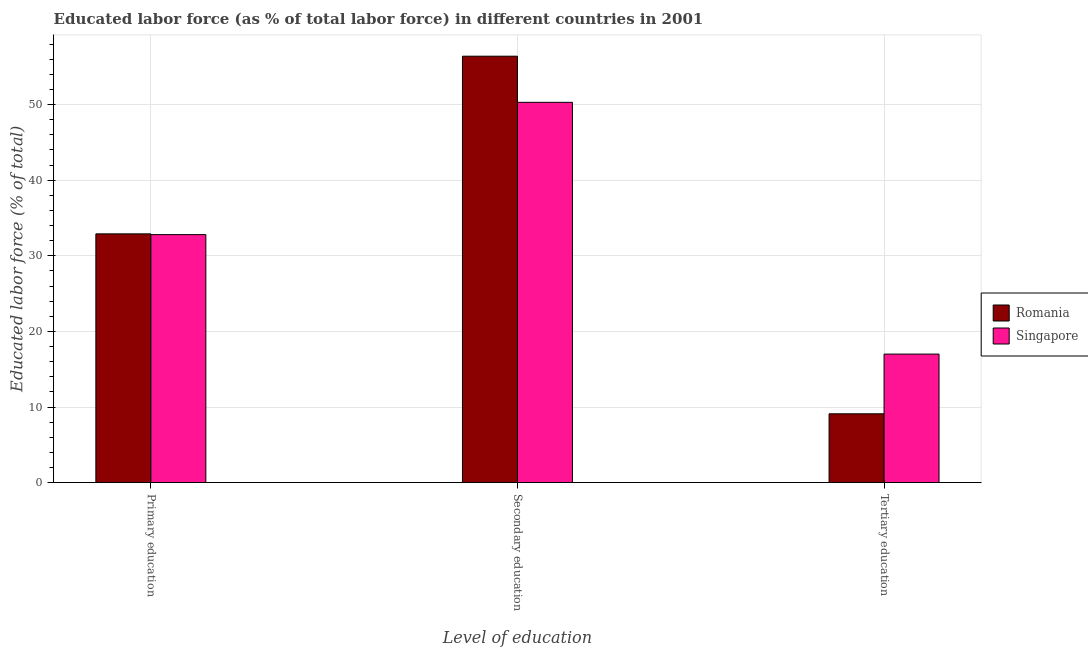How many groups of bars are there?
Offer a terse response. 3. How many bars are there on the 1st tick from the left?
Keep it short and to the point. 2. What is the label of the 1st group of bars from the left?
Keep it short and to the point. Primary education. Across all countries, what is the maximum percentage of labor force who received secondary education?
Your answer should be very brief. 56.4. Across all countries, what is the minimum percentage of labor force who received primary education?
Give a very brief answer. 32.8. In which country was the percentage of labor force who received tertiary education maximum?
Your response must be concise. Singapore. In which country was the percentage of labor force who received primary education minimum?
Your answer should be compact. Singapore. What is the total percentage of labor force who received tertiary education in the graph?
Provide a succinct answer. 26.1. What is the difference between the percentage of labor force who received primary education in Singapore and that in Romania?
Offer a terse response. -0.1. What is the difference between the percentage of labor force who received secondary education in Singapore and the percentage of labor force who received tertiary education in Romania?
Provide a short and direct response. 41.2. What is the average percentage of labor force who received secondary education per country?
Your answer should be compact. 53.35. What is the difference between the percentage of labor force who received secondary education and percentage of labor force who received tertiary education in Romania?
Offer a terse response. 47.3. In how many countries, is the percentage of labor force who received tertiary education greater than 48 %?
Offer a terse response. 0. What is the ratio of the percentage of labor force who received secondary education in Singapore to that in Romania?
Your answer should be compact. 0.89. Is the percentage of labor force who received tertiary education in Romania less than that in Singapore?
Ensure brevity in your answer.  Yes. What is the difference between the highest and the second highest percentage of labor force who received secondary education?
Offer a terse response. 6.1. What is the difference between the highest and the lowest percentage of labor force who received tertiary education?
Provide a succinct answer. 7.9. Is the sum of the percentage of labor force who received secondary education in Romania and Singapore greater than the maximum percentage of labor force who received primary education across all countries?
Give a very brief answer. Yes. What does the 1st bar from the left in Primary education represents?
Your response must be concise. Romania. What does the 1st bar from the right in Secondary education represents?
Your answer should be compact. Singapore. How many bars are there?
Make the answer very short. 6. How many countries are there in the graph?
Ensure brevity in your answer.  2. What is the difference between two consecutive major ticks on the Y-axis?
Ensure brevity in your answer.  10. Does the graph contain grids?
Give a very brief answer. Yes. Where does the legend appear in the graph?
Make the answer very short. Center right. How many legend labels are there?
Keep it short and to the point. 2. How are the legend labels stacked?
Your response must be concise. Vertical. What is the title of the graph?
Keep it short and to the point. Educated labor force (as % of total labor force) in different countries in 2001. What is the label or title of the X-axis?
Ensure brevity in your answer.  Level of education. What is the label or title of the Y-axis?
Provide a succinct answer. Educated labor force (% of total). What is the Educated labor force (% of total) in Romania in Primary education?
Ensure brevity in your answer.  32.9. What is the Educated labor force (% of total) of Singapore in Primary education?
Provide a succinct answer. 32.8. What is the Educated labor force (% of total) in Romania in Secondary education?
Make the answer very short. 56.4. What is the Educated labor force (% of total) of Singapore in Secondary education?
Keep it short and to the point. 50.3. What is the Educated labor force (% of total) of Romania in Tertiary education?
Give a very brief answer. 9.1. Across all Level of education, what is the maximum Educated labor force (% of total) in Romania?
Your response must be concise. 56.4. Across all Level of education, what is the maximum Educated labor force (% of total) in Singapore?
Keep it short and to the point. 50.3. Across all Level of education, what is the minimum Educated labor force (% of total) in Romania?
Offer a very short reply. 9.1. What is the total Educated labor force (% of total) in Romania in the graph?
Give a very brief answer. 98.4. What is the total Educated labor force (% of total) of Singapore in the graph?
Ensure brevity in your answer.  100.1. What is the difference between the Educated labor force (% of total) of Romania in Primary education and that in Secondary education?
Keep it short and to the point. -23.5. What is the difference between the Educated labor force (% of total) in Singapore in Primary education and that in Secondary education?
Offer a terse response. -17.5. What is the difference between the Educated labor force (% of total) of Romania in Primary education and that in Tertiary education?
Ensure brevity in your answer.  23.8. What is the difference between the Educated labor force (% of total) of Singapore in Primary education and that in Tertiary education?
Make the answer very short. 15.8. What is the difference between the Educated labor force (% of total) in Romania in Secondary education and that in Tertiary education?
Provide a short and direct response. 47.3. What is the difference between the Educated labor force (% of total) of Singapore in Secondary education and that in Tertiary education?
Provide a succinct answer. 33.3. What is the difference between the Educated labor force (% of total) of Romania in Primary education and the Educated labor force (% of total) of Singapore in Secondary education?
Offer a very short reply. -17.4. What is the difference between the Educated labor force (% of total) of Romania in Primary education and the Educated labor force (% of total) of Singapore in Tertiary education?
Your answer should be compact. 15.9. What is the difference between the Educated labor force (% of total) of Romania in Secondary education and the Educated labor force (% of total) of Singapore in Tertiary education?
Provide a short and direct response. 39.4. What is the average Educated labor force (% of total) in Romania per Level of education?
Your response must be concise. 32.8. What is the average Educated labor force (% of total) in Singapore per Level of education?
Provide a succinct answer. 33.37. What is the difference between the Educated labor force (% of total) in Romania and Educated labor force (% of total) in Singapore in Primary education?
Ensure brevity in your answer.  0.1. What is the difference between the Educated labor force (% of total) in Romania and Educated labor force (% of total) in Singapore in Secondary education?
Give a very brief answer. 6.1. What is the ratio of the Educated labor force (% of total) of Romania in Primary education to that in Secondary education?
Make the answer very short. 0.58. What is the ratio of the Educated labor force (% of total) of Singapore in Primary education to that in Secondary education?
Offer a very short reply. 0.65. What is the ratio of the Educated labor force (% of total) in Romania in Primary education to that in Tertiary education?
Make the answer very short. 3.62. What is the ratio of the Educated labor force (% of total) of Singapore in Primary education to that in Tertiary education?
Make the answer very short. 1.93. What is the ratio of the Educated labor force (% of total) of Romania in Secondary education to that in Tertiary education?
Give a very brief answer. 6.2. What is the ratio of the Educated labor force (% of total) of Singapore in Secondary education to that in Tertiary education?
Offer a terse response. 2.96. What is the difference between the highest and the second highest Educated labor force (% of total) of Romania?
Offer a terse response. 23.5. What is the difference between the highest and the second highest Educated labor force (% of total) in Singapore?
Keep it short and to the point. 17.5. What is the difference between the highest and the lowest Educated labor force (% of total) of Romania?
Your answer should be very brief. 47.3. What is the difference between the highest and the lowest Educated labor force (% of total) in Singapore?
Keep it short and to the point. 33.3. 